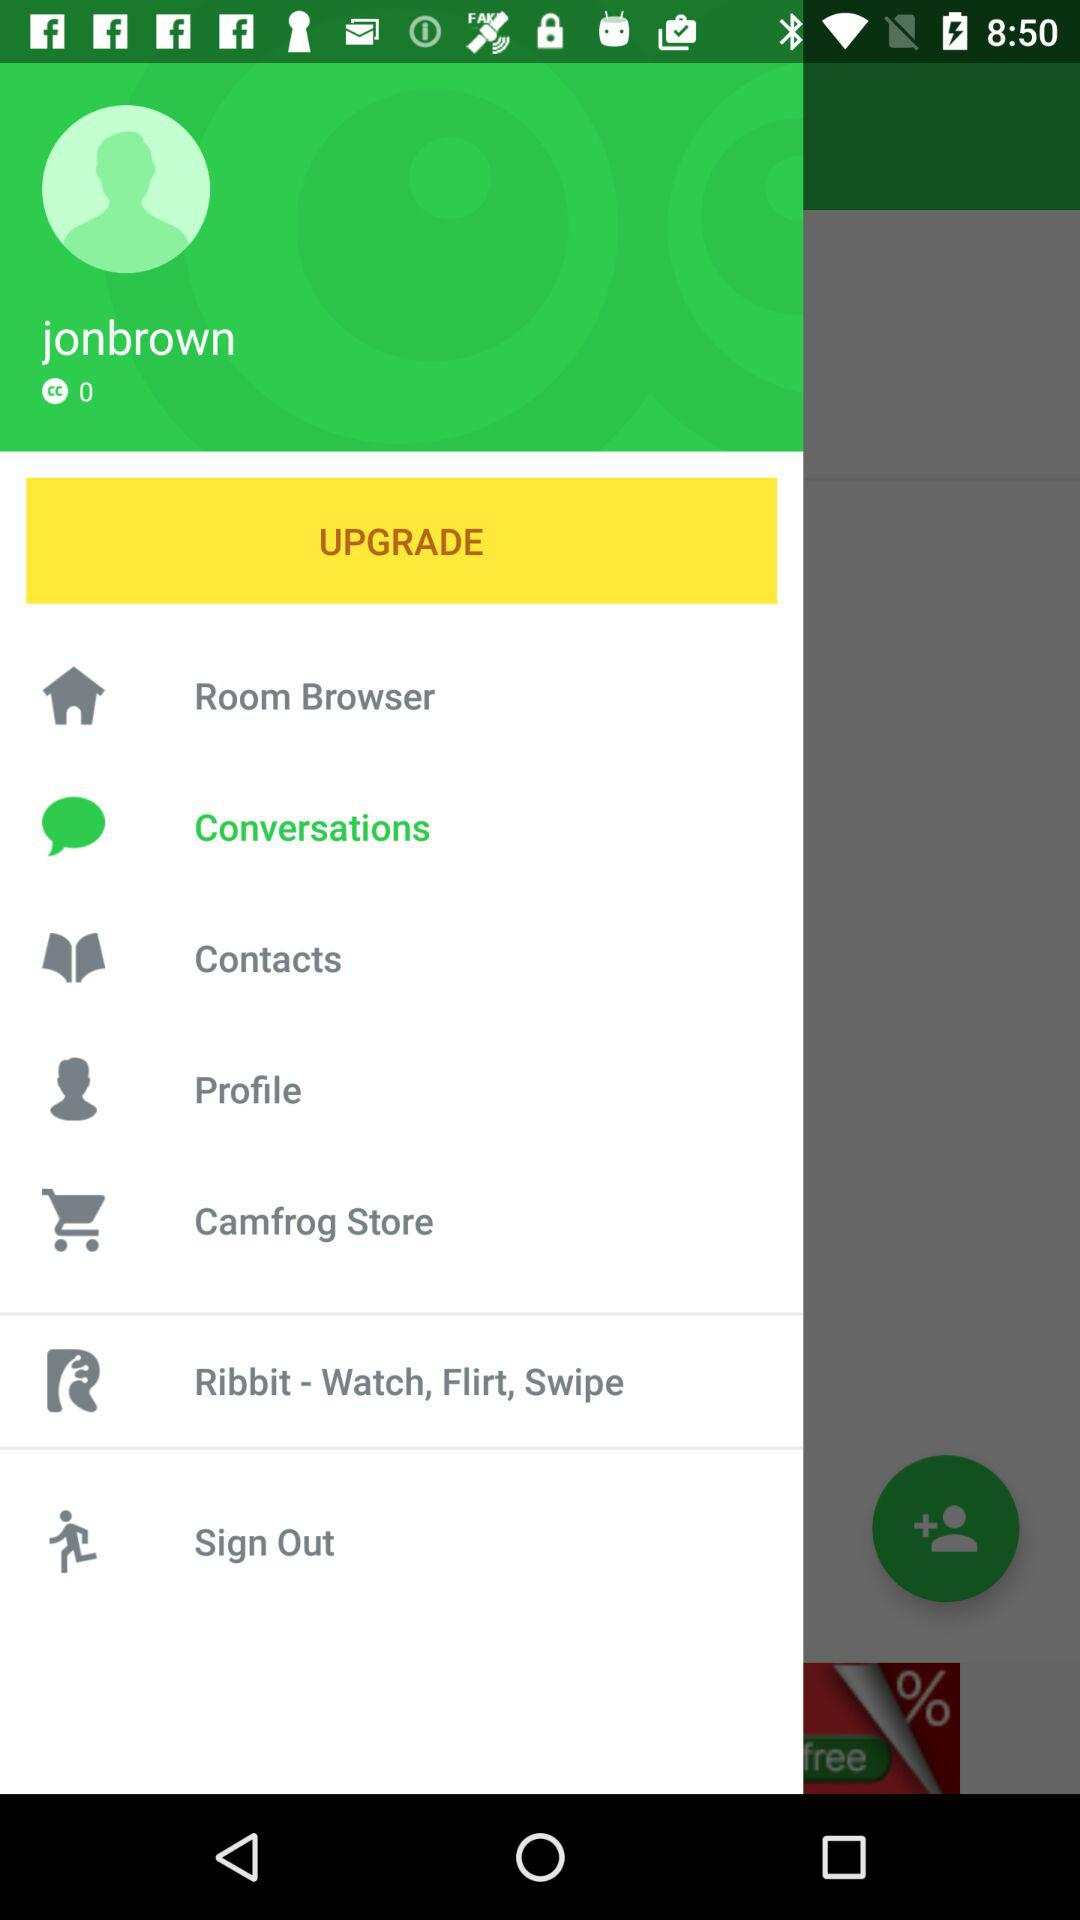What is the user name? The user name is Jonbrown. 